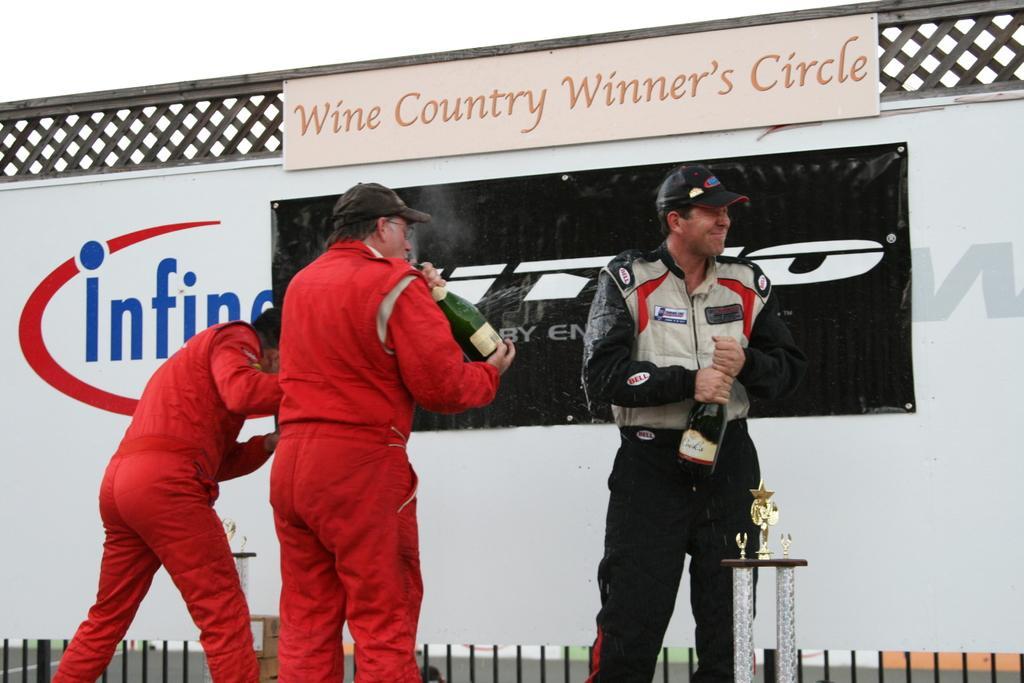Can you describe this image briefly? In this image I can see three people with red, black and ash color dresses. I can see two people with the caps and these people are holding the wine bottles. In the back there is a board which is colorful. I can also see the sky in the back. 